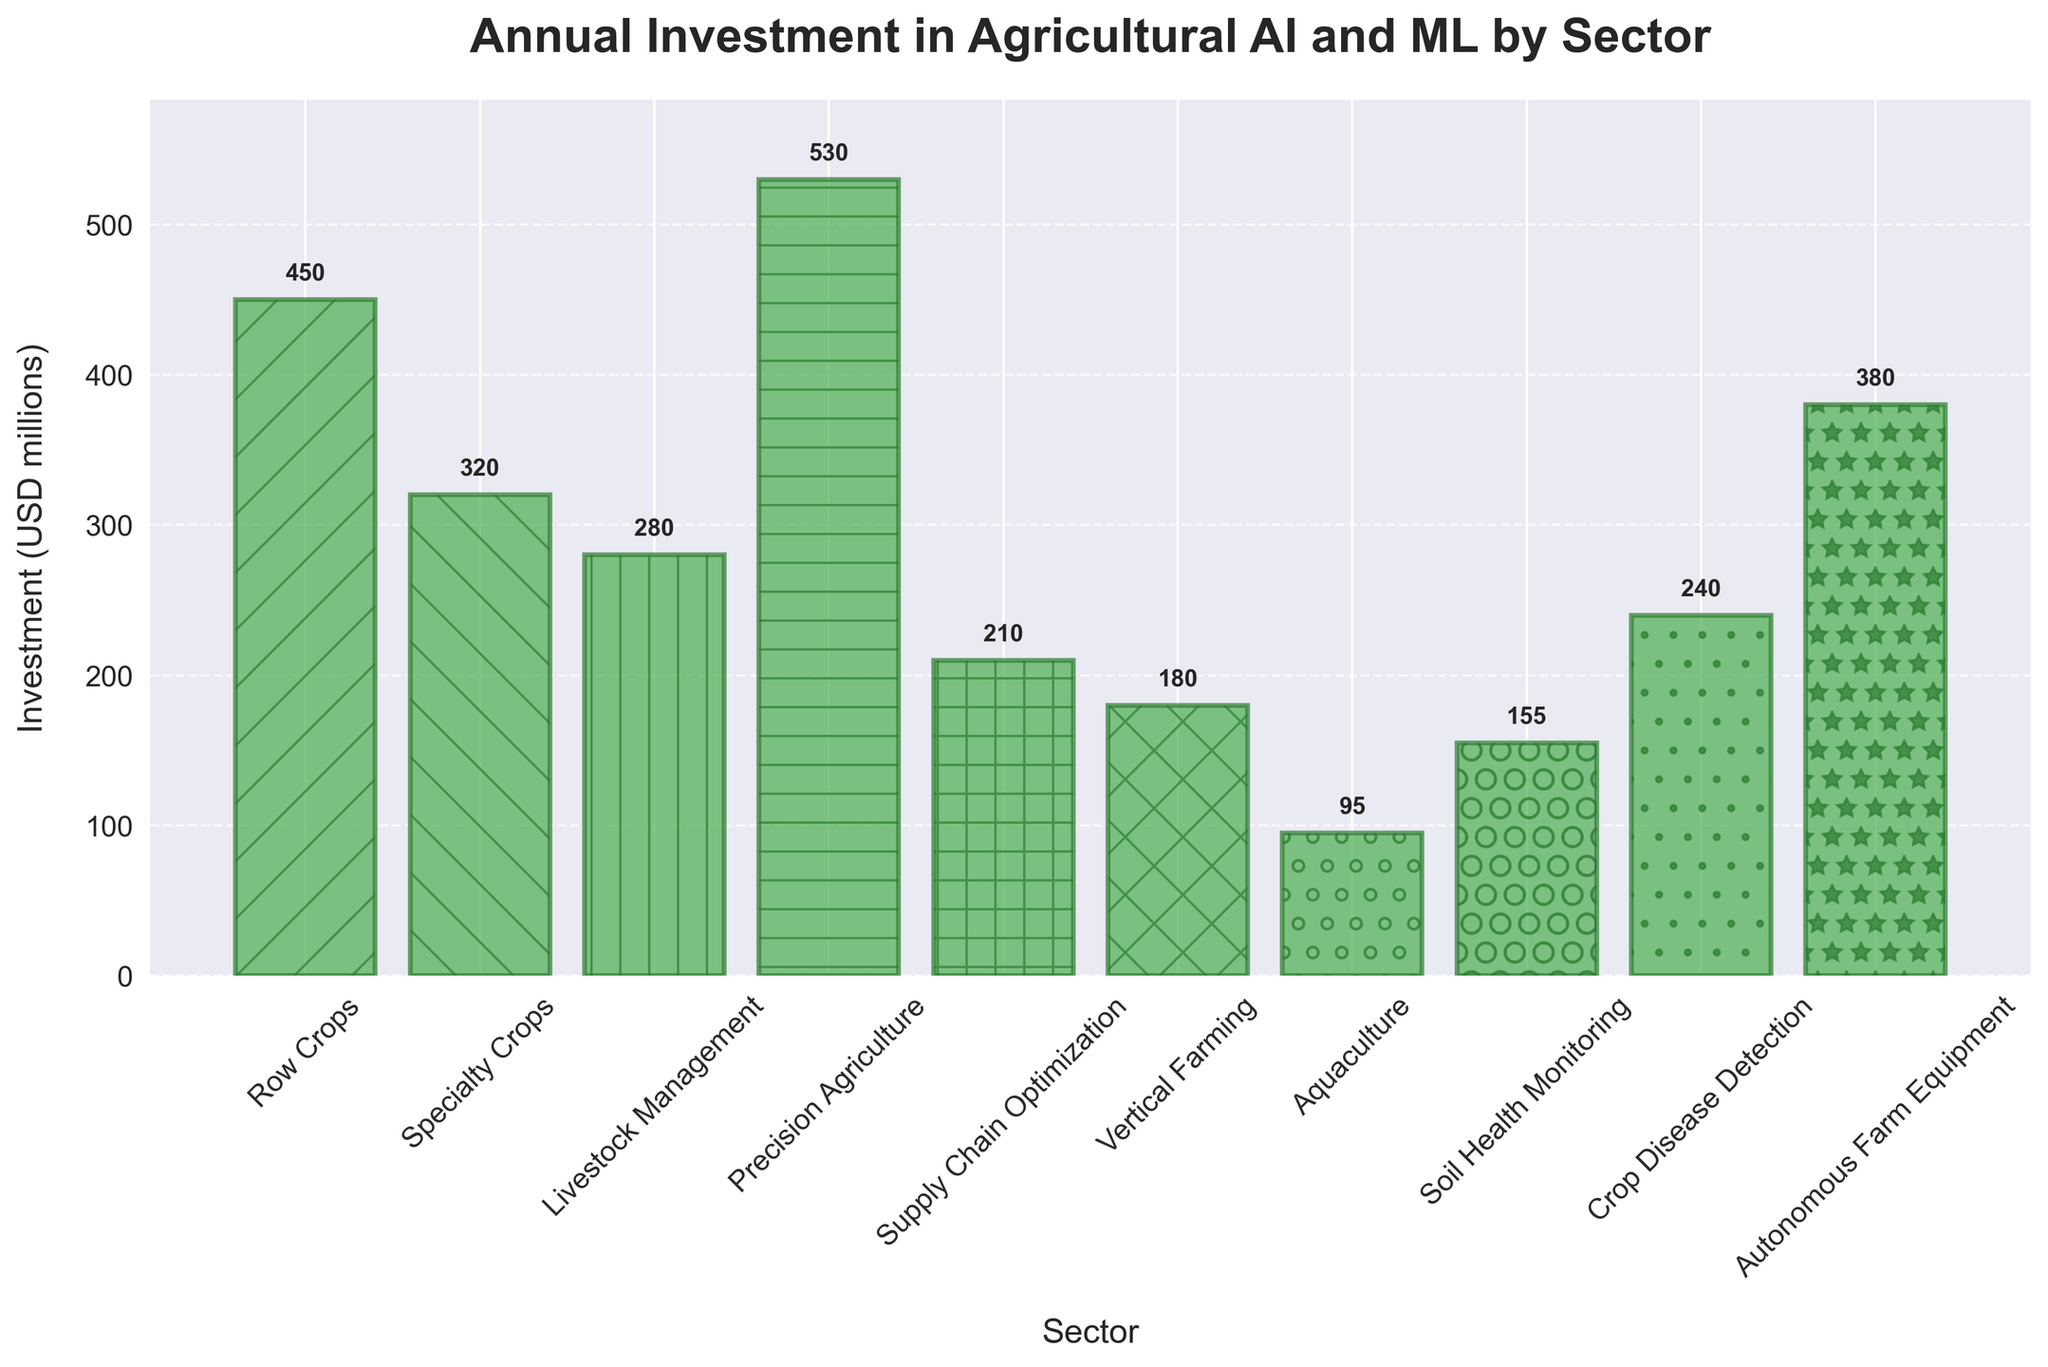Which sector has the highest annual investment? By comparing the heights of the bars, the sector with the highest bar is "Precision Agriculture".
Answer: Precision Agriculture Which sector has the lowest annual investment? By comparing the heights of the bars, the sector with the lowest bar is "Aquaculture".
Answer: Aquaculture What is the combined investment in 'Row Crops' and 'Specialty Crops'? 'Row Crops' has an investment of 450 million, and 'Specialty Crops' has an investment of 320 million. Summing these values: 450 + 320 = 770 million.
Answer: 770 million How much more is invested in 'Autonomous Farm Equipment' compared to 'Vertical Farming'? 'Autonomous Farm Equipment' has an investment of 380 million, and 'Vertical Farming' has an investment of 180 million. The difference is 380 - 180 = 200 million.
Answer: 200 million What is the average investment across all sectors? To find the average, sum all the investments and divide by the number of sectors. Total investment = 450 + 320 + 280 + 530 + 210 + 180 + 95 + 155 + 240 + 380 = 2840 million. Average = 2840 / 10 = 284 million.
Answer: 284 million Which sector falls in the middle of the pack in terms of investment? When the investments are ordered, the middle values are 240 (Crop Disease Detection) and 280 (Livestock Management). The median of these two is 260. "Livestock Management" falls closer to the median than "Crop Disease Detection".
Answer: Livestock Management Is the investment in 'Supply Chain Optimization' greater than 'Soil Health Monitoring'? 'Supply Chain Optimization' has an investment of 210 million, and 'Soil Health Monitoring' has an investment of 155 million. 210 is greater than 155.
Answer: Yes What is the difference between the highest and lowest investments? The highest investment is in 'Precision Agriculture' at 530 million, and the lowest is in 'Aquaculture' at 95 million. The difference is 530 - 95 = 435 million.
Answer: 435 million Which three sectors have investments closest to 300 million? The sectors with investments closest to 300 million are 'Specialty Crops' (320 million), 'Livestock Management' (280 million), and 'Crop Disease Detection' (240 million).
Answer: Specialty Crops, Livestock Management, Crop Disease Detection What is the total investment in all sectors related to crops ('Row Crops', 'Specialty Crops', 'Precision Agriculture', 'Crop Disease Detection')? The investment in 'Row Crops' is 450 million, 'Specialty Crops' is 320 million, 'Precision Agriculture' is 530 million, and 'Crop Disease Detection' is 240 million. Summing these: 450 + 320 + 530 + 240 = 1540 million.
Answer: 1540 million 